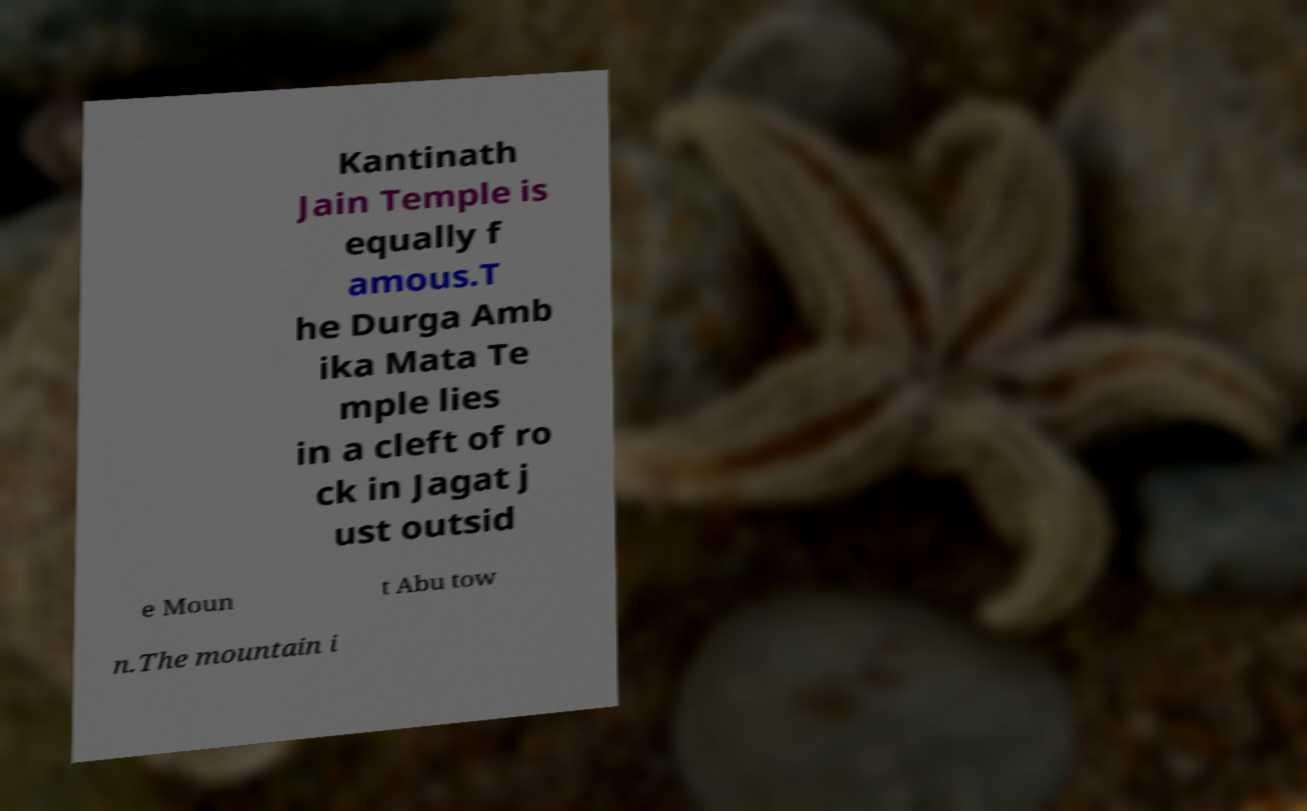Can you read and provide the text displayed in the image?This photo seems to have some interesting text. Can you extract and type it out for me? Kantinath Jain Temple is equally f amous.T he Durga Amb ika Mata Te mple lies in a cleft of ro ck in Jagat j ust outsid e Moun t Abu tow n.The mountain i 